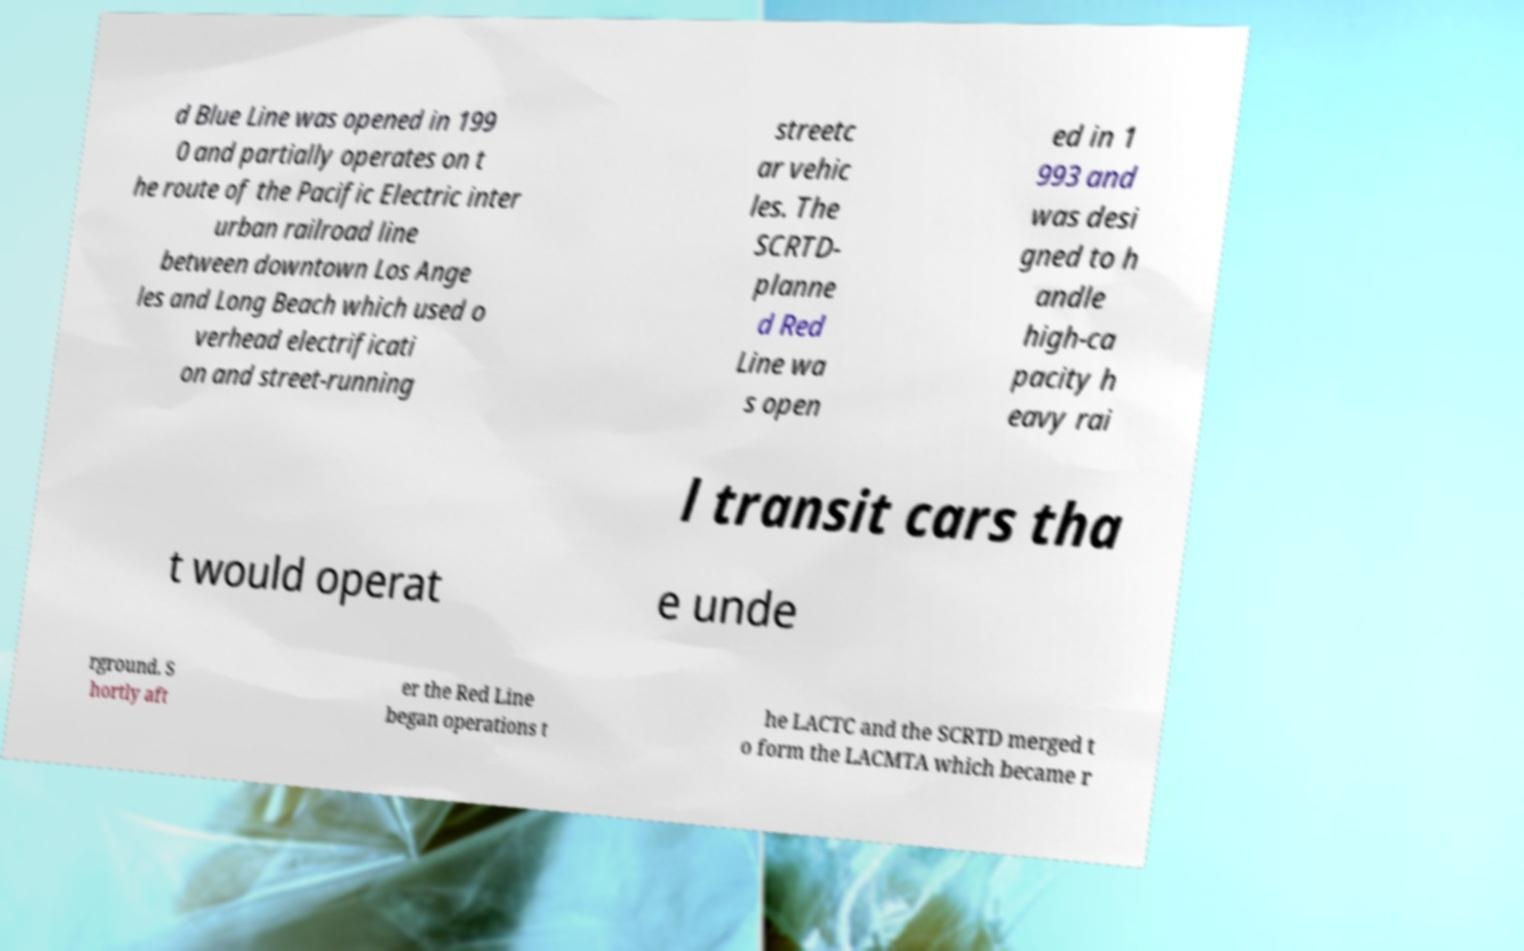Please read and relay the text visible in this image. What does it say? d Blue Line was opened in 199 0 and partially operates on t he route of the Pacific Electric inter urban railroad line between downtown Los Ange les and Long Beach which used o verhead electrificati on and street-running streetc ar vehic les. The SCRTD- planne d Red Line wa s open ed in 1 993 and was desi gned to h andle high-ca pacity h eavy rai l transit cars tha t would operat e unde rground. S hortly aft er the Red Line began operations t he LACTC and the SCRTD merged t o form the LACMTA which became r 